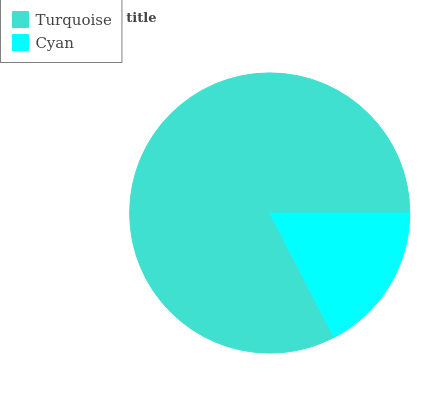Is Cyan the minimum?
Answer yes or no. Yes. Is Turquoise the maximum?
Answer yes or no. Yes. Is Cyan the maximum?
Answer yes or no. No. Is Turquoise greater than Cyan?
Answer yes or no. Yes. Is Cyan less than Turquoise?
Answer yes or no. Yes. Is Cyan greater than Turquoise?
Answer yes or no. No. Is Turquoise less than Cyan?
Answer yes or no. No. Is Turquoise the high median?
Answer yes or no. Yes. Is Cyan the low median?
Answer yes or no. Yes. Is Cyan the high median?
Answer yes or no. No. Is Turquoise the low median?
Answer yes or no. No. 